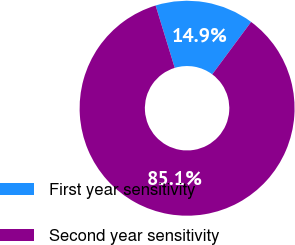Convert chart to OTSL. <chart><loc_0><loc_0><loc_500><loc_500><pie_chart><fcel>First year sensitivity<fcel>Second year sensitivity<nl><fcel>14.89%<fcel>85.11%<nl></chart> 